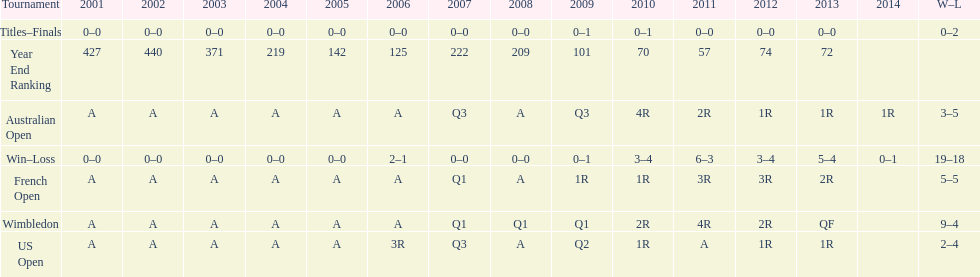Which year end ranking was higher, 2004 or 2011? 2011. 